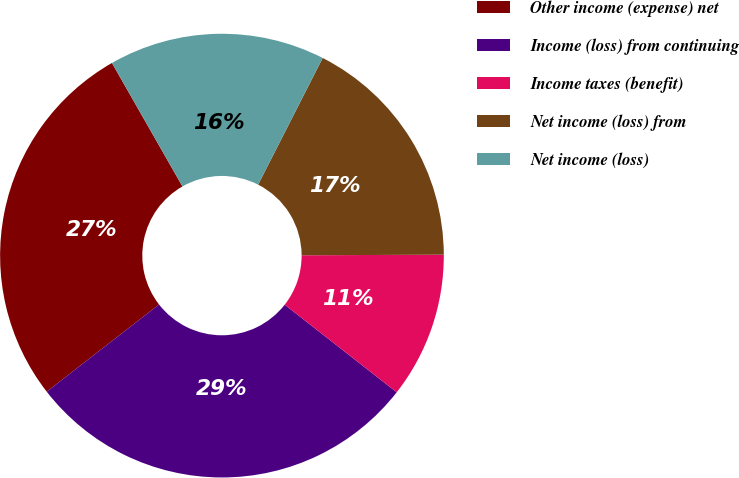Convert chart. <chart><loc_0><loc_0><loc_500><loc_500><pie_chart><fcel>Other income (expense) net<fcel>Income (loss) from continuing<fcel>Income taxes (benefit)<fcel>Net income (loss) from<fcel>Net income (loss)<nl><fcel>27.25%<fcel>28.93%<fcel>10.63%<fcel>17.43%<fcel>15.76%<nl></chart> 